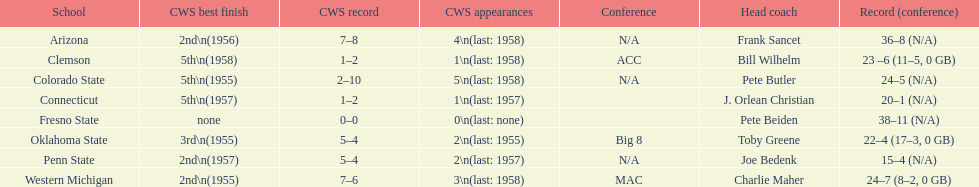Which was the only team with less than 20 wins? Penn State. 